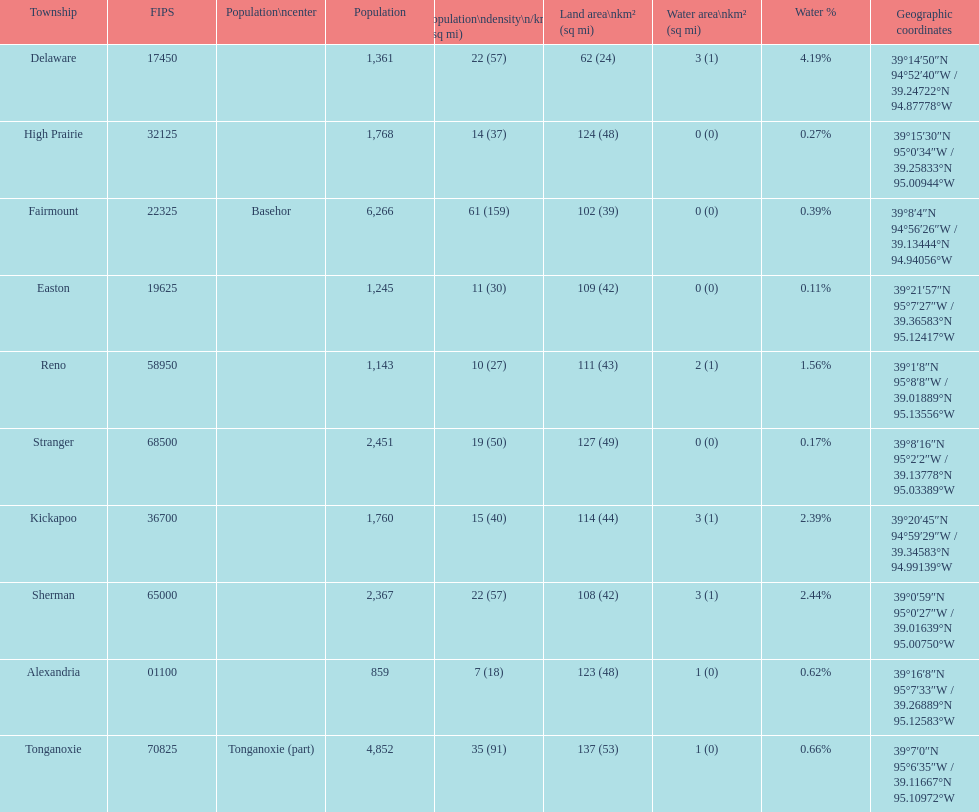What township has the largest population? Fairmount. 